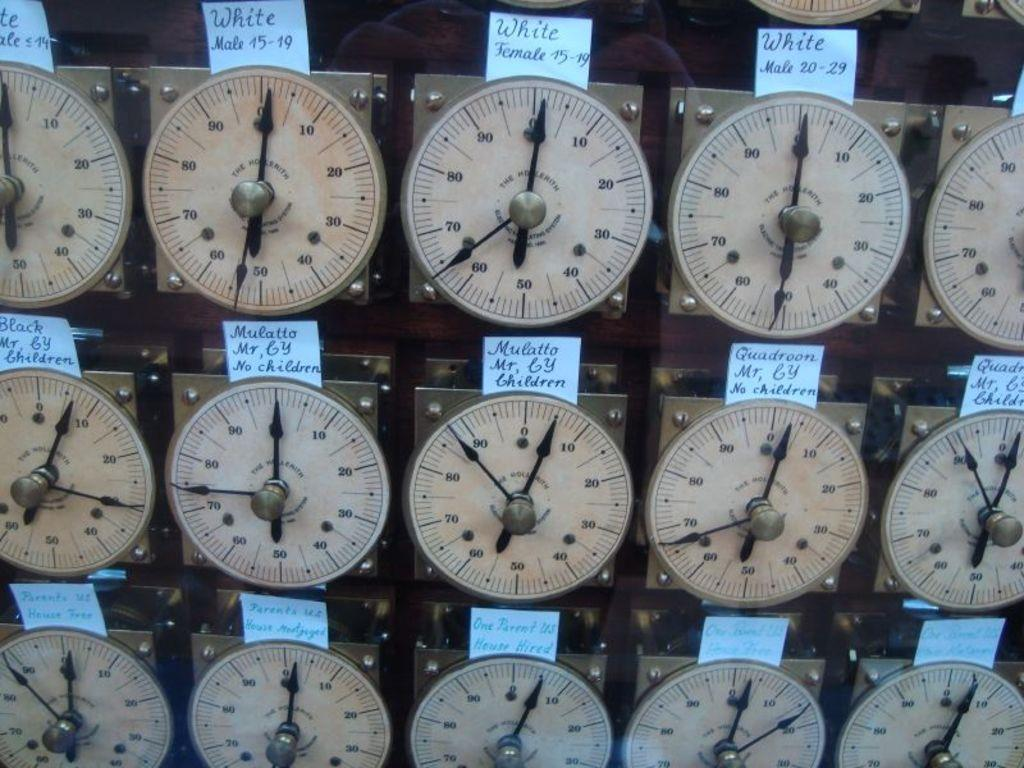<image>
Write a terse but informative summary of the picture. The top row of meters shown say the word White above them 